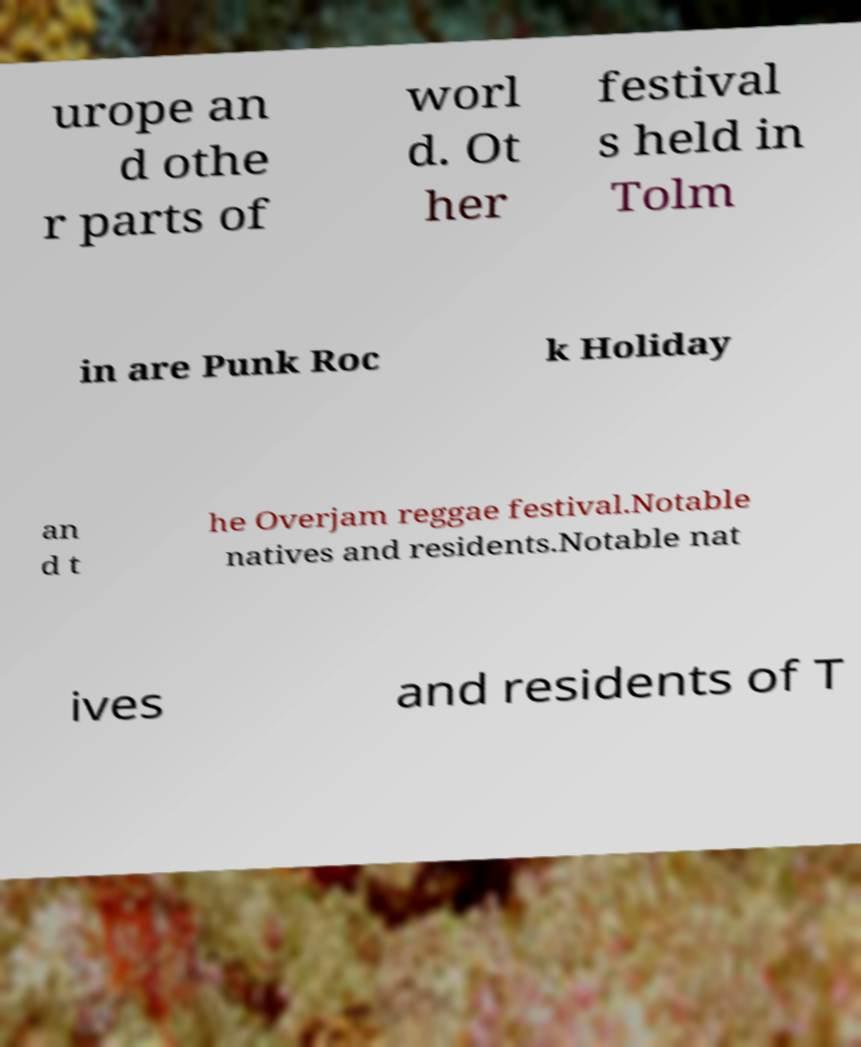Can you accurately transcribe the text from the provided image for me? urope an d othe r parts of worl d. Ot her festival s held in Tolm in are Punk Roc k Holiday an d t he Overjam reggae festival.Notable natives and residents.Notable nat ives and residents of T 